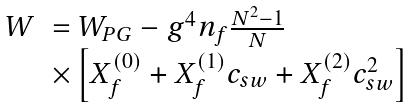<formula> <loc_0><loc_0><loc_500><loc_500>\begin{array} { l l } W & = W _ { P G } - g ^ { 4 } n _ { f } \frac { N ^ { 2 } - 1 } { N } \\ & \times \left [ X _ { f } ^ { ( 0 ) } + X _ { f } ^ { ( 1 ) } c _ { s w } + X _ { f } ^ { ( 2 ) } c _ { s w } ^ { 2 } \right ] \end{array}</formula> 